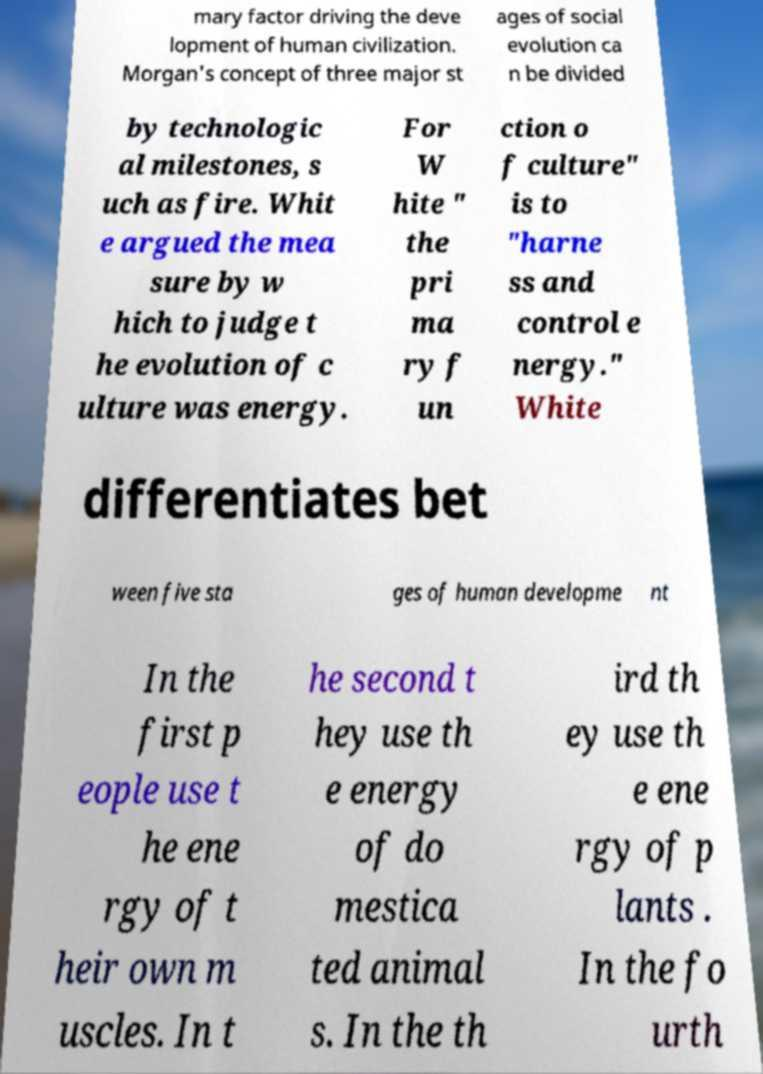For documentation purposes, I need the text within this image transcribed. Could you provide that? mary factor driving the deve lopment of human civilization. Morgan's concept of three major st ages of social evolution ca n be divided by technologic al milestones, s uch as fire. Whit e argued the mea sure by w hich to judge t he evolution of c ulture was energy. For W hite " the pri ma ry f un ction o f culture" is to "harne ss and control e nergy." White differentiates bet ween five sta ges of human developme nt In the first p eople use t he ene rgy of t heir own m uscles. In t he second t hey use th e energy of do mestica ted animal s. In the th ird th ey use th e ene rgy of p lants . In the fo urth 